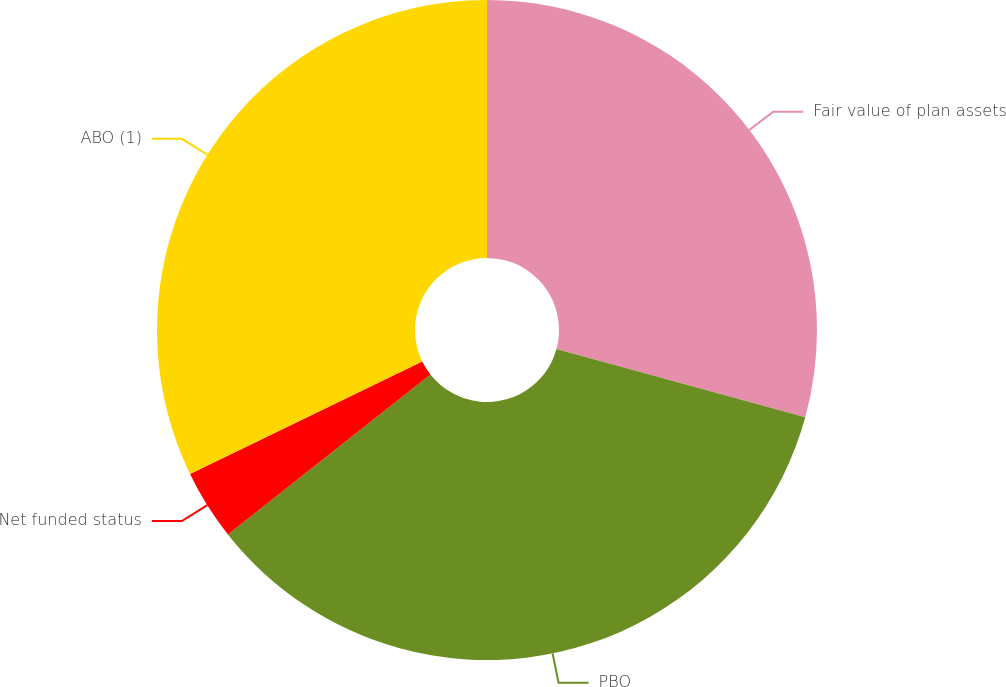Convert chart. <chart><loc_0><loc_0><loc_500><loc_500><pie_chart><fcel>Fair value of plan assets<fcel>PBO<fcel>Net funded status<fcel>ABO (1)<nl><fcel>29.26%<fcel>35.11%<fcel>3.45%<fcel>32.18%<nl></chart> 